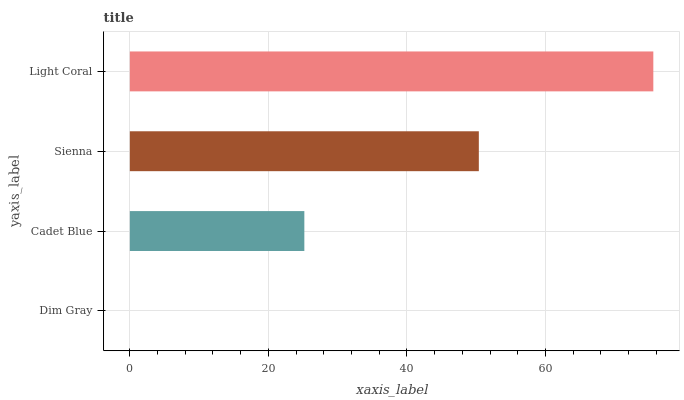Is Dim Gray the minimum?
Answer yes or no. Yes. Is Light Coral the maximum?
Answer yes or no. Yes. Is Cadet Blue the minimum?
Answer yes or no. No. Is Cadet Blue the maximum?
Answer yes or no. No. Is Cadet Blue greater than Dim Gray?
Answer yes or no. Yes. Is Dim Gray less than Cadet Blue?
Answer yes or no. Yes. Is Dim Gray greater than Cadet Blue?
Answer yes or no. No. Is Cadet Blue less than Dim Gray?
Answer yes or no. No. Is Sienna the high median?
Answer yes or no. Yes. Is Cadet Blue the low median?
Answer yes or no. Yes. Is Light Coral the high median?
Answer yes or no. No. Is Light Coral the low median?
Answer yes or no. No. 